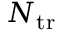Convert formula to latex. <formula><loc_0><loc_0><loc_500><loc_500>N _ { t r }</formula> 